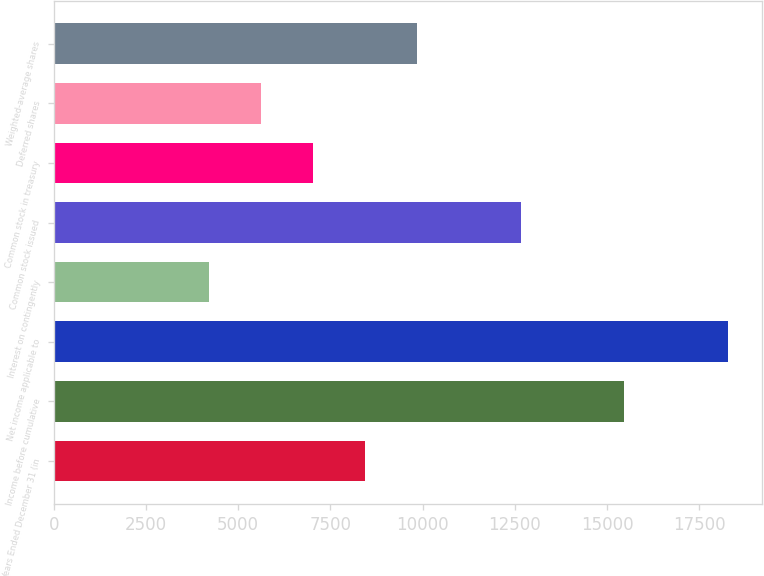Convert chart. <chart><loc_0><loc_0><loc_500><loc_500><bar_chart><fcel>Years Ended December 31 (in<fcel>Income before cumulative<fcel>Net income applicable to<fcel>Interest on contingently<fcel>Common stock issued<fcel>Common stock in treasury<fcel>Deferred shares<fcel>Weighted-average shares<nl><fcel>8436.95<fcel>15463.2<fcel>18273.8<fcel>4221.17<fcel>12652.7<fcel>7031.69<fcel>5626.43<fcel>9842.21<nl></chart> 